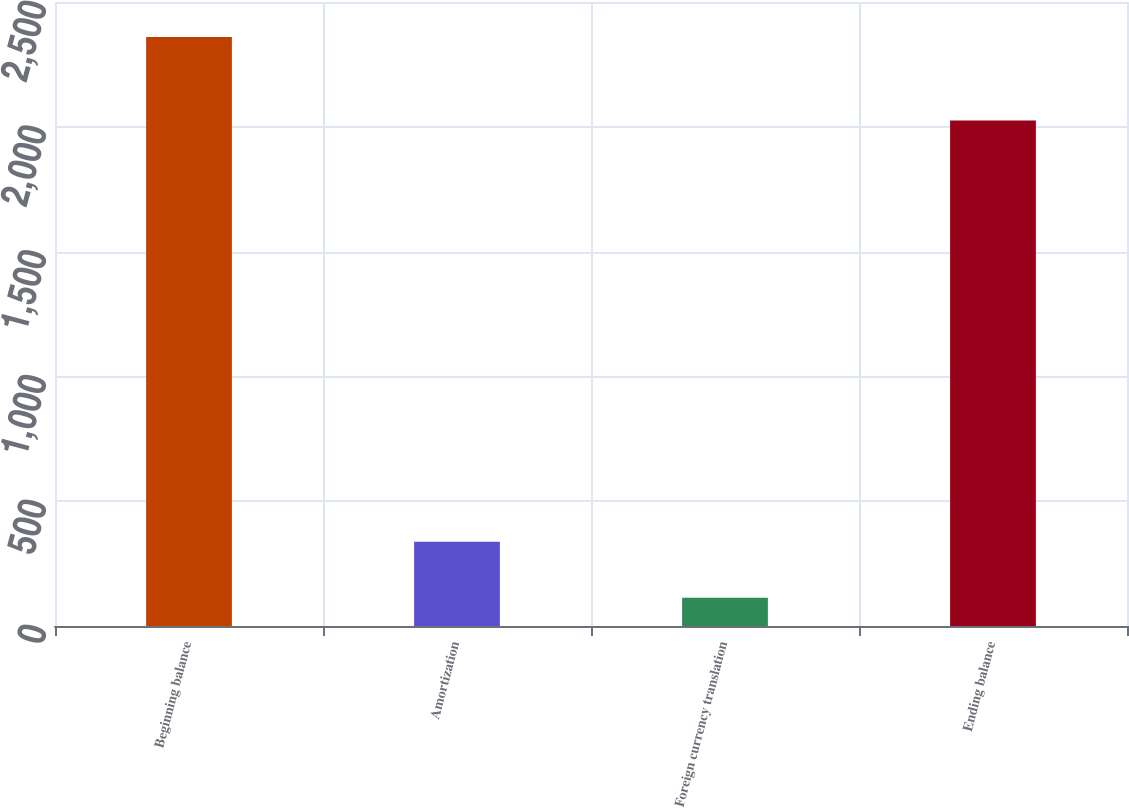Convert chart. <chart><loc_0><loc_0><loc_500><loc_500><bar_chart><fcel>Beginning balance<fcel>Amortization<fcel>Foreign currency translation<fcel>Ending balance<nl><fcel>2360<fcel>337.7<fcel>113<fcel>2025<nl></chart> 